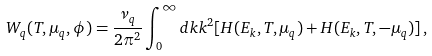Convert formula to latex. <formula><loc_0><loc_0><loc_500><loc_500>W _ { q } ( T , \mu _ { q } , \phi ) = \frac { \nu _ { q } } { 2 \pi ^ { 2 } } \int _ { 0 } ^ { \infty } d k k ^ { 2 } [ H ( E _ { k } , T , \mu _ { q } ) + H ( E _ { k } , T , - \mu _ { q } ) ] \, ,</formula> 